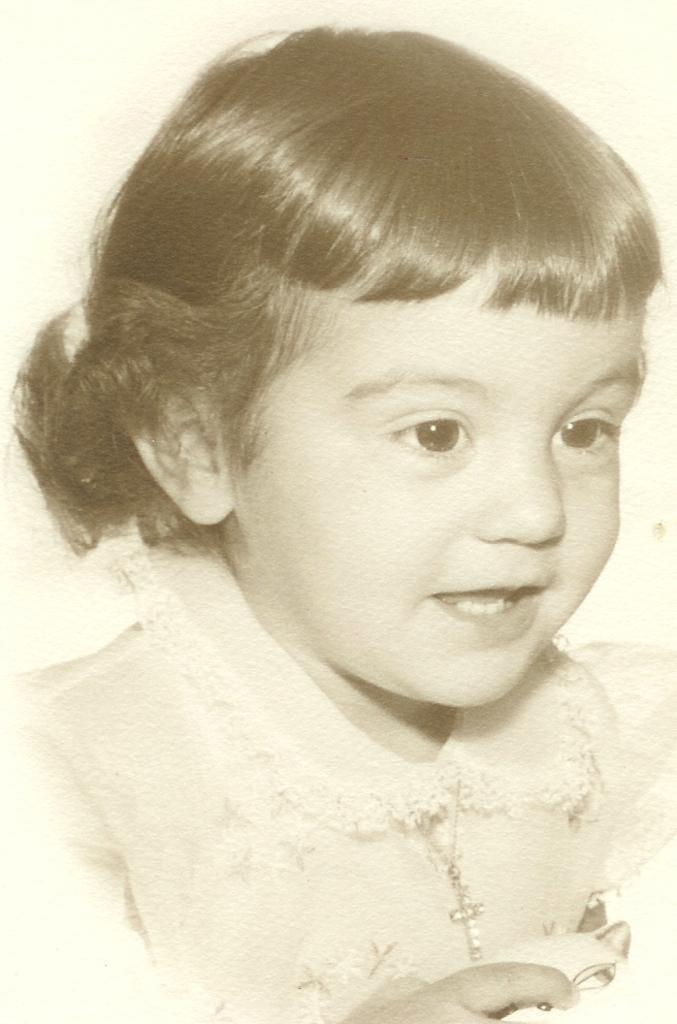What is the color scheme of the image? The image is black and white. Who is present in the image? There is a girl in the image. What is the girl's expression in the image? The girl is smiling in the image. What type of art can be seen in the middle of the stream in the image? There is no art or stream present in the image; it features a girl in a black and white setting. 